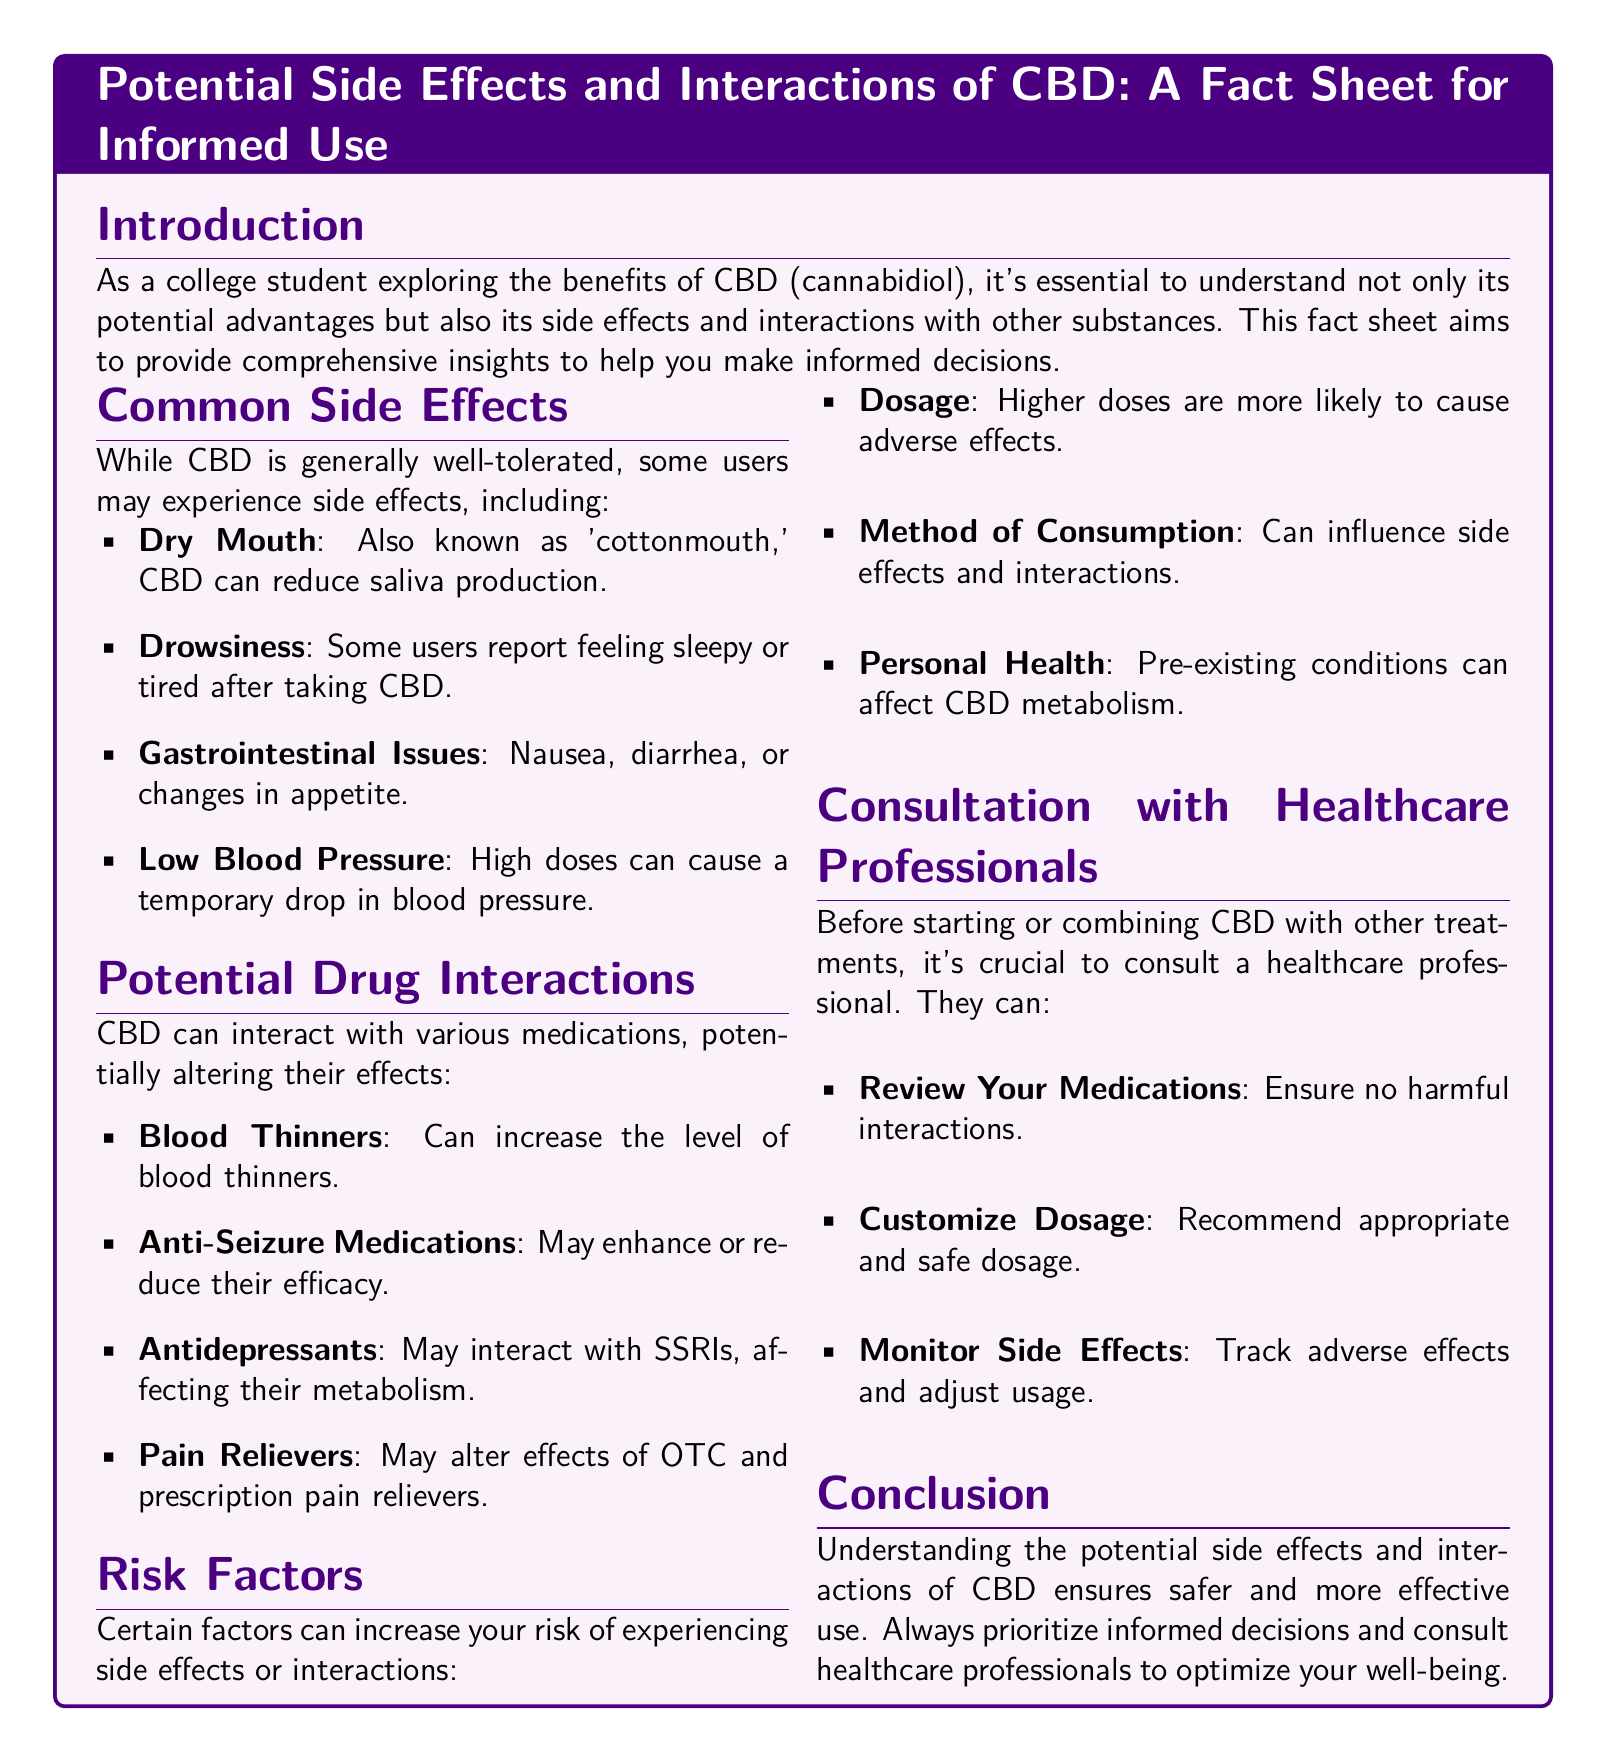What are some common side effects of CBD? The document lists common side effects including dry mouth, drowsiness, gastrointestinal issues, and low blood pressure.
Answer: dry mouth, drowsiness, gastrointestinal issues, low blood pressure What should you do before combining CBD with other treatments? The document suggests that you should consult a healthcare professional before starting or combining CBD with other treatments.
Answer: consult a healthcare professional What risk factor relates to the method of consumption? The document identifies that the method of consumption can influence side effects and interactions with CBD.
Answer: method of consumption Which medication class may have altered effects when combined with CBD? The document mentions blood thinners as a medication class that could have altered effects due to CBD interactions.
Answer: blood thinners What is a potential gastrointestinal issue mentioned? The document lists nausea as one of the gastrointestinal issues that may occur with CBD use.
Answer: nausea Name one factor that increases the risk of experiencing side effects with CBD. The document mentions dosage as one risk factor that can increase the likelihood of experiencing side effects.
Answer: dosage Which type of healthcare professional should you consult according to the document? The document advises consulting a healthcare professional for guidance on CBD usage and potential interactions.
Answer: healthcare professional How may CBD interact with antidepressants? The document states that CBD may interact with SSRIs, affecting their metabolism.
Answer: affect their metabolism What does the conclusion emphasize regarding CBD use? The conclusion emphasizes the importance of understanding potential side effects and interactions for safer use of CBD.
Answer: understanding potential side effects and interactions 